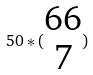<formula> <loc_0><loc_0><loc_500><loc_500>5 0 * ( \begin{matrix} 6 6 \\ 7 \end{matrix} )</formula> 